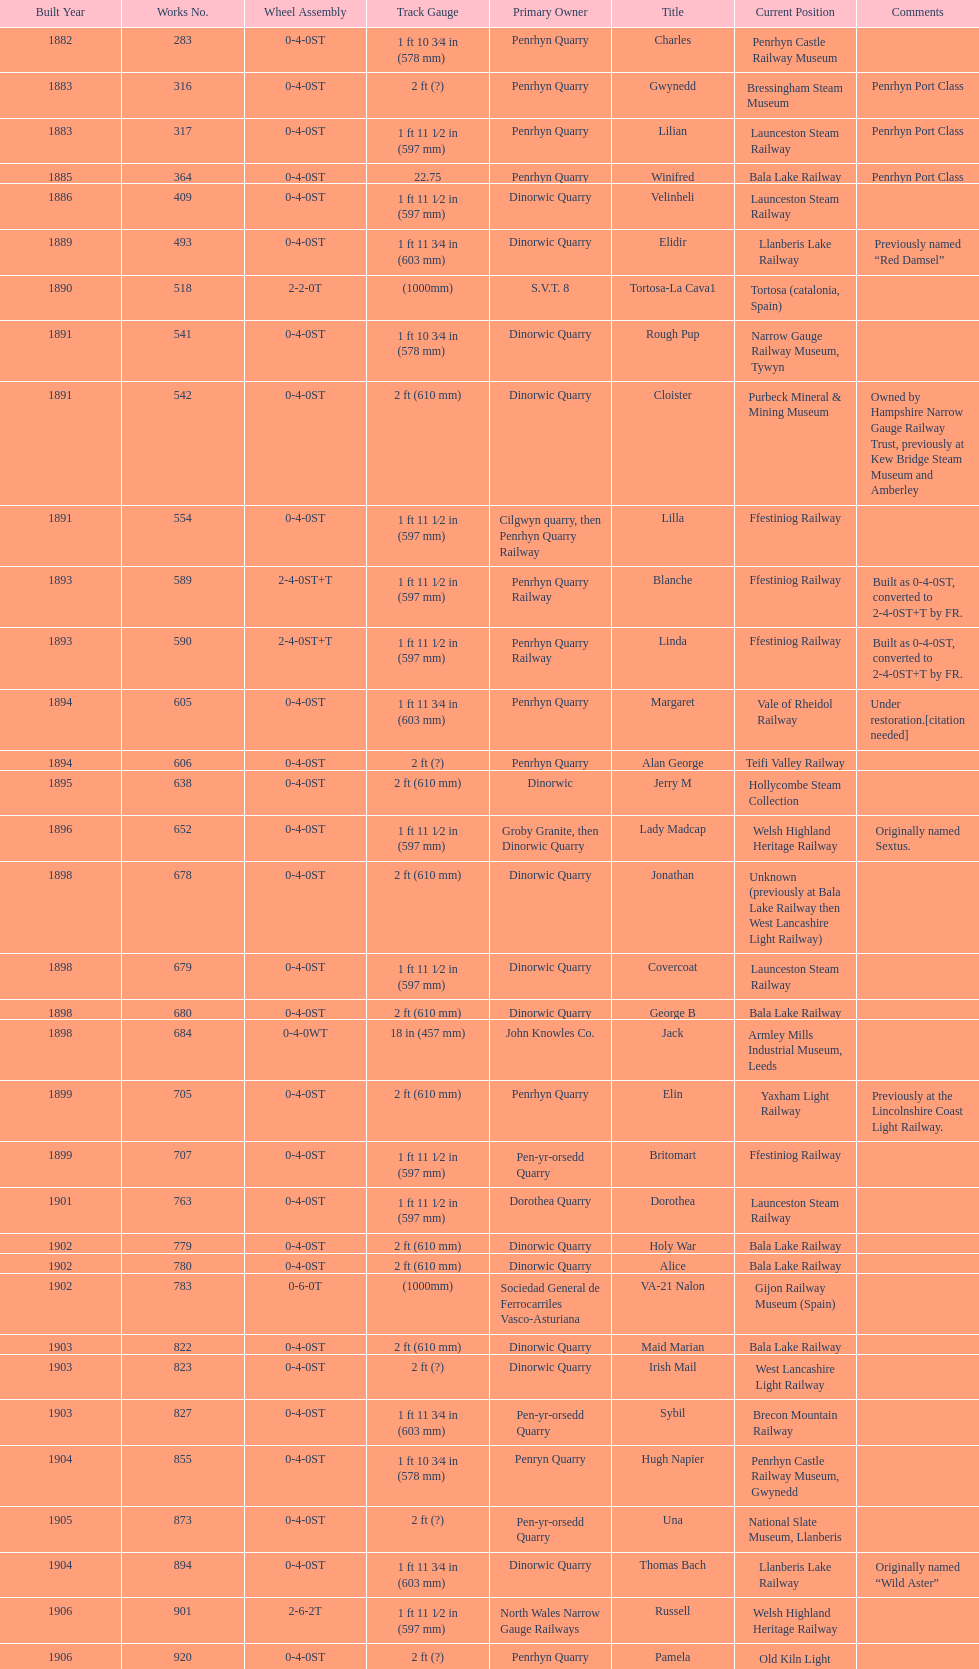Which works number had a larger gauge, 283 or 317? 317. 